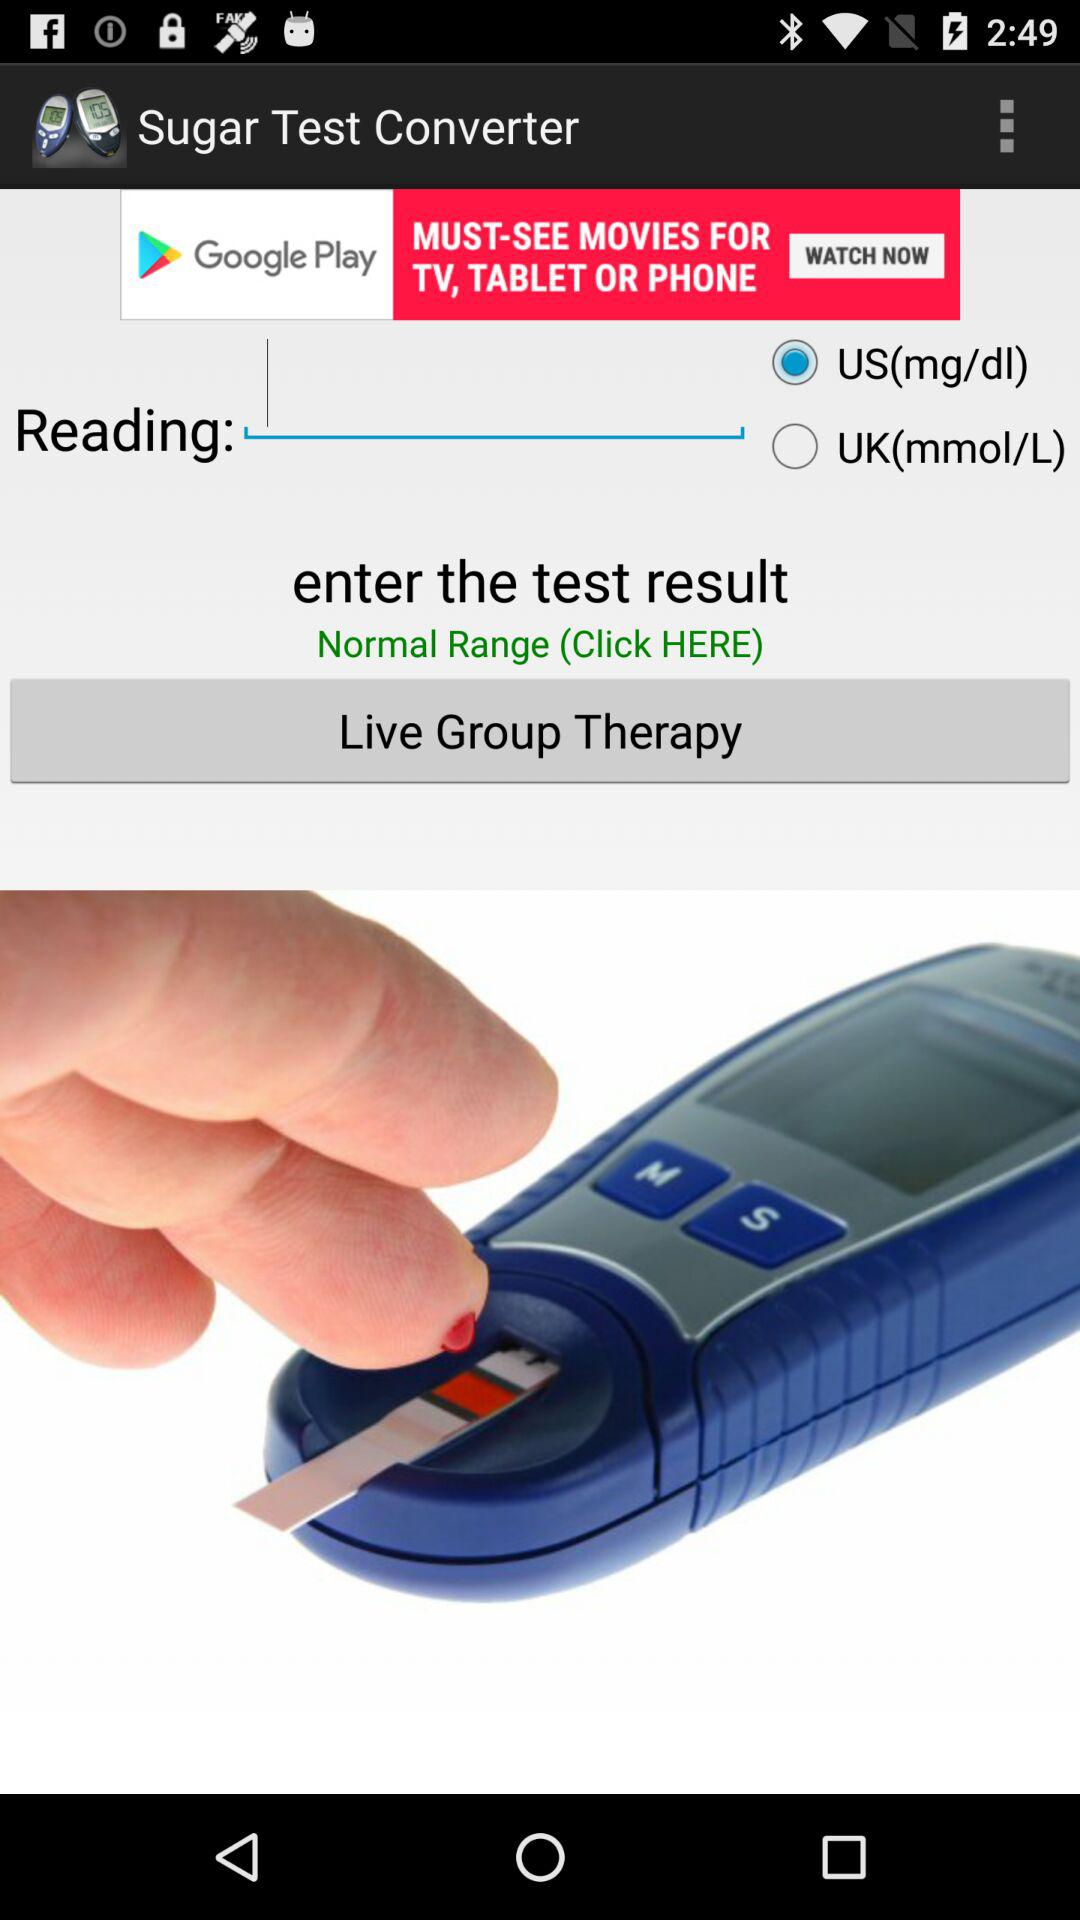Which reading was selected? The selected reading was "US(mg/dl)". 